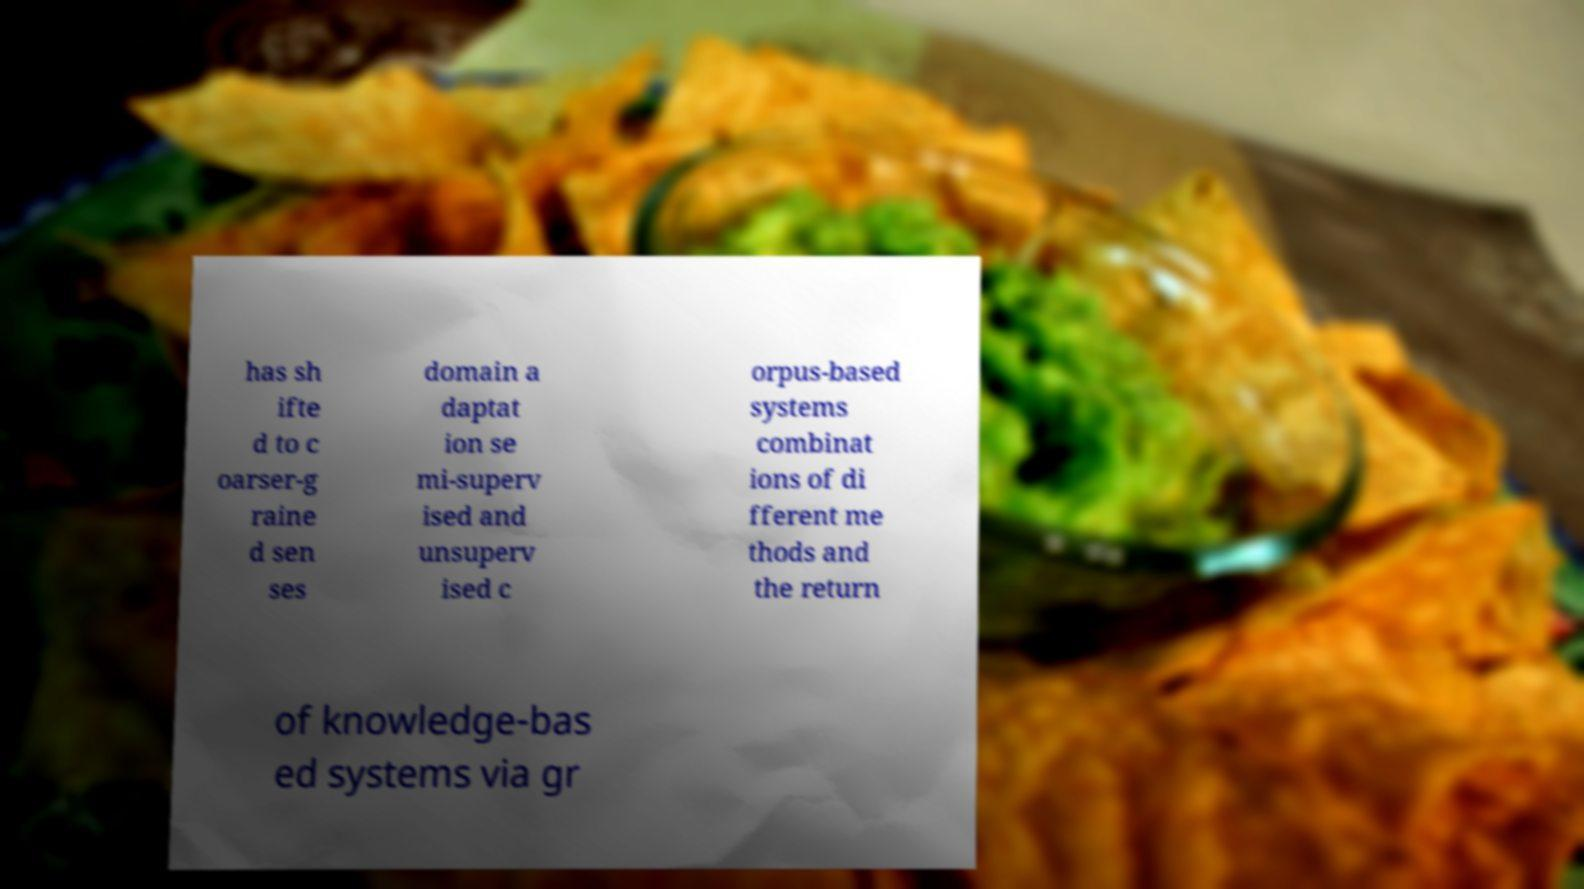I need the written content from this picture converted into text. Can you do that? has sh ifte d to c oarser-g raine d sen ses domain a daptat ion se mi-superv ised and unsuperv ised c orpus-based systems combinat ions of di fferent me thods and the return of knowledge-bas ed systems via gr 